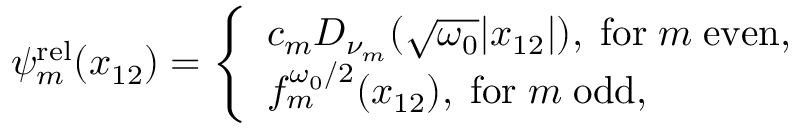<formula> <loc_0><loc_0><loc_500><loc_500>\begin{array} { r } { \psi _ { m } ^ { r e l } ( x _ { 1 2 } ) = \left \{ \begin{array} { l l } { c _ { m } D _ { \nu _ { m } } ( \sqrt { \omega _ { 0 } } | x _ { 1 2 } | ) , \, f o r \, m \, e v e n , } \\ { f _ { m } ^ { \omega _ { 0 } / 2 } ( x _ { 1 2 } ) , \, f o r \, m \, o d d , } \end{array} } \end{array}</formula> 